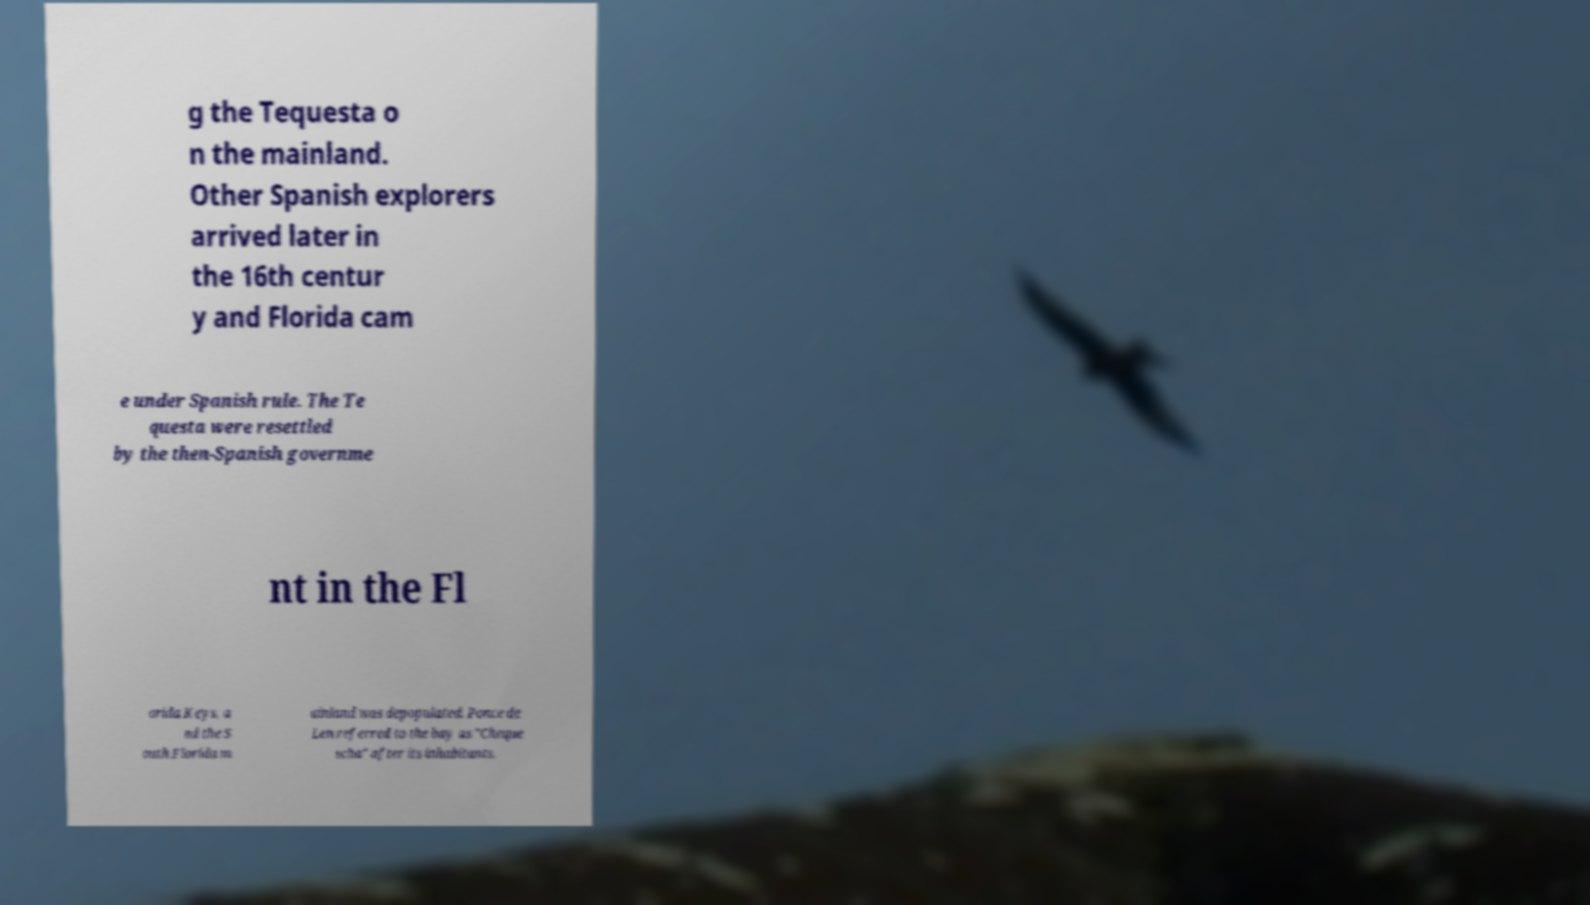Can you read and provide the text displayed in the image?This photo seems to have some interesting text. Can you extract and type it out for me? g the Tequesta o n the mainland. Other Spanish explorers arrived later in the 16th centur y and Florida cam e under Spanish rule. The Te questa were resettled by the then-Spanish governme nt in the Fl orida Keys, a nd the S outh Florida m ainland was depopulated. Ponce de Len referred to the bay as "Cheque scha" after its inhabitants, 